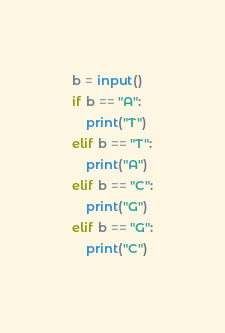Convert code to text. <code><loc_0><loc_0><loc_500><loc_500><_Python_>b = input()
if b == "A":
    print("T")
elif b == "T":
    print("A")
elif b == "C":
    print("G")
elif b == "G":
    print("C")</code> 